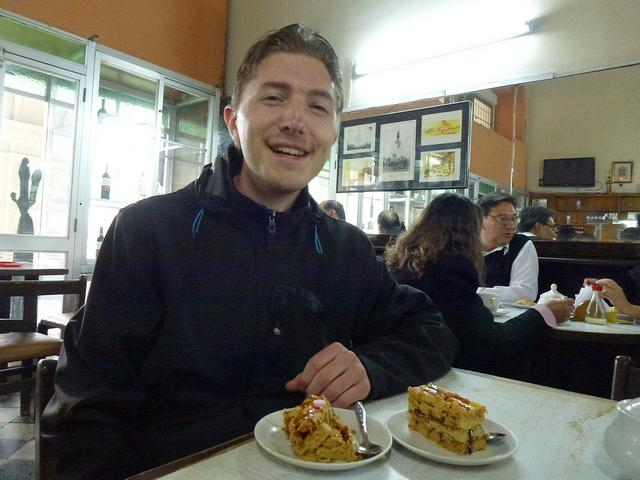What type food is this man enjoying?

Choices:
A) pizza
B) soup
C) dessert food
D) salad dessert food 